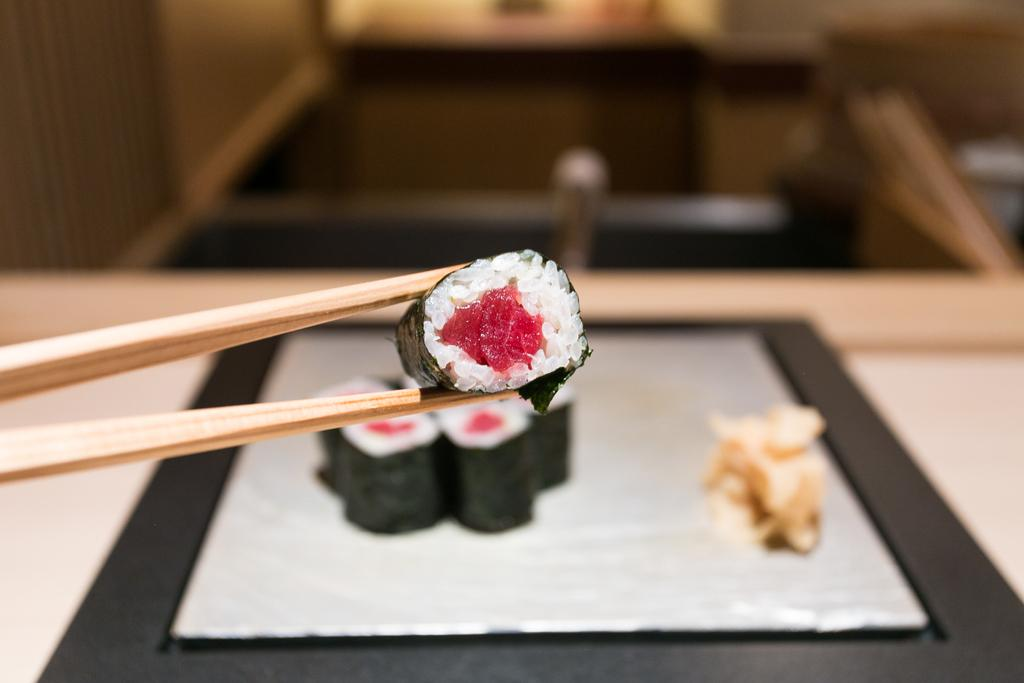What is on the plate that is visible in the image? There is a plate of food in the image. What utensil is present in the image? There is a spoon with food in the image. What type of squirrel can be seen climbing on the plate of food in the image? There is no squirrel present in the image; it only features a plate of food and a spoon with food. What kind of beast is interacting with the spoon in the image? There is no beast present in the image; only the plate of food and the spoon with food are visible. 